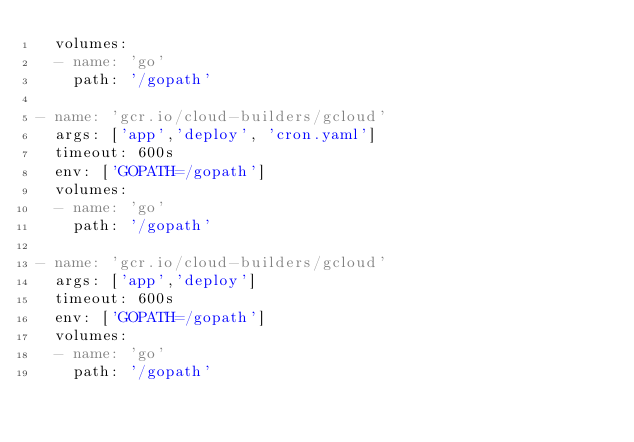Convert code to text. <code><loc_0><loc_0><loc_500><loc_500><_YAML_>  volumes:
  - name: 'go'
    path: '/gopath'

- name: 'gcr.io/cloud-builders/gcloud'
  args: ['app','deploy', 'cron.yaml']
  timeout: 600s
  env: ['GOPATH=/gopath']
  volumes:
  - name: 'go'
    path: '/gopath'

- name: 'gcr.io/cloud-builders/gcloud'
  args: ['app','deploy']
  timeout: 600s
  env: ['GOPATH=/gopath']
  volumes:
  - name: 'go'
    path: '/gopath'

</code> 